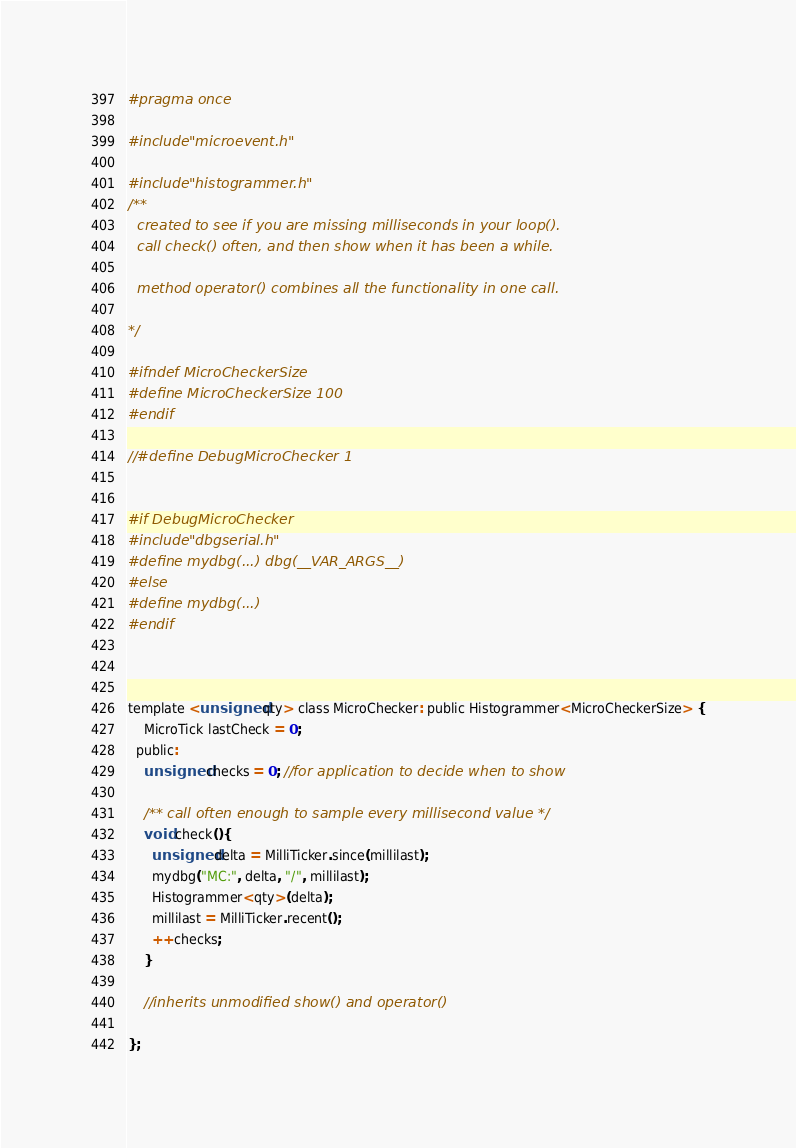Convert code to text. <code><loc_0><loc_0><loc_500><loc_500><_C_>#pragma once

#include "microevent.h"

#include "histogrammer.h" 
/**
  created to see if you are missing milliseconds in your loop().
  call check() often, and then show when it has been a while.

  method operator() combines all the functionality in one call.

*/

#ifndef MicroCheckerSize
#define MicroCheckerSize 100
#endif

//#define DebugMicroChecker 1


#if DebugMicroChecker
#include "dbgserial.h"
#define mydbg(...) dbg(__VAR_ARGS__)
#else
#define mydbg(...)
#endif



template <unsigned qty> class MicroChecker: public Histogrammer<MicroCheckerSize> {
    MicroTick lastCheck = 0;
  public:
    unsigned checks = 0; //for application to decide when to show

    /** call often enough to sample every millisecond value */
    void check(){
      unsigned delta = MilliTicker.since(millilast);
      mydbg("MC:", delta, "/", millilast);
      Histogrammer<qty>(delta);
      millilast = MilliTicker.recent();
      ++checks;
    }

    //inherits unmodified show() and operator()

};
</code> 